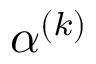Convert formula to latex. <formula><loc_0><loc_0><loc_500><loc_500>\alpha ^ { ( k ) }</formula> 